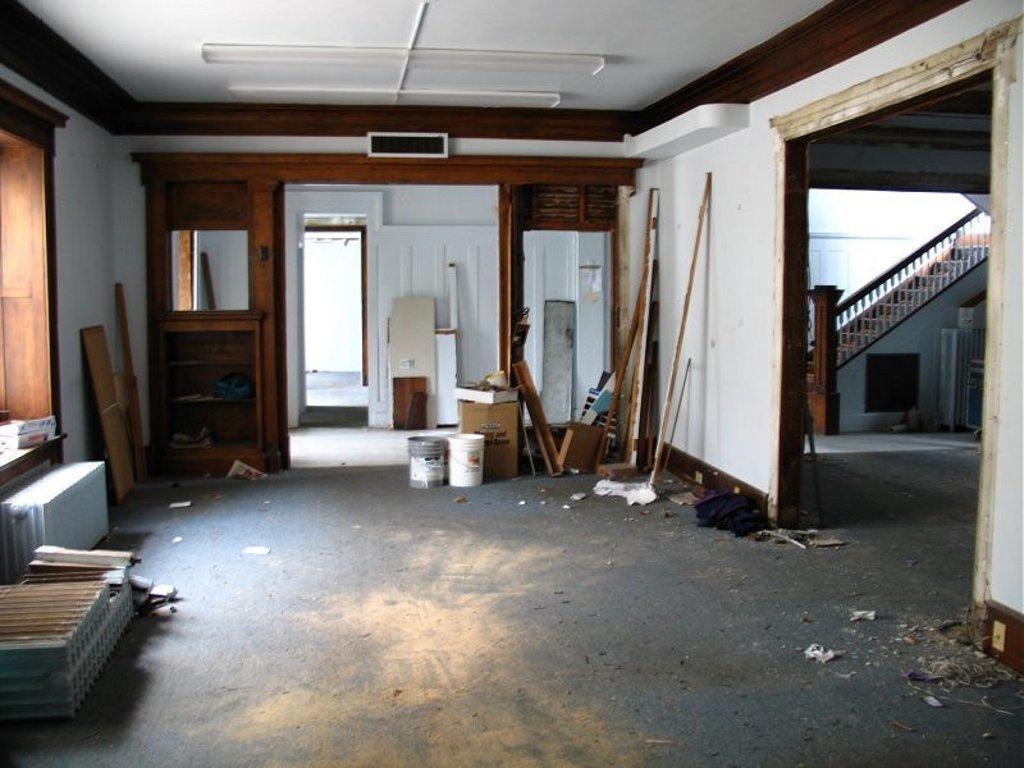How would you summarize this image in a sentence or two? In this picture there is a inside view of the hall, which is renovating. In the front there is a wooden rack and a door. On the right side we can see stairs and wooden railing. On the left side there are some stones and wooden rafters. 